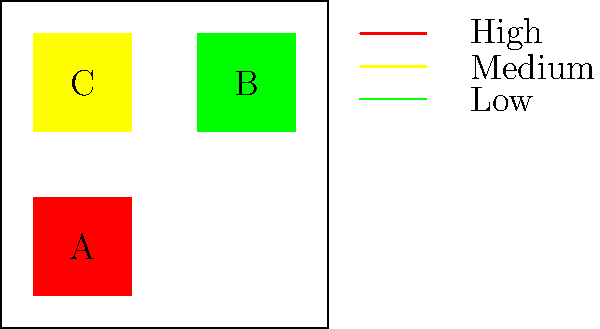Based on the heatmap of visitor engagement in the museum layout, which exhibit area should be prioritized for improvement to increase overall visitor engagement? To determine which exhibit area should be prioritized for improvement, we need to analyze the heatmap and consider the following steps:

1. Interpret the heatmap colors:
   - Red (region A): High engagement
   - Yellow (region C): Medium engagement
   - Green (region B): Low engagement

2. Assess the current engagement levels:
   - Region A is already performing well with high engagement
   - Region C has moderate engagement
   - Region B has the lowest engagement

3. Consider the potential for improvement:
   - Improving the highest-performing area (A) may yield diminishing returns
   - The medium-performing area (C) has some room for improvement
   - The lowest-performing area (B) has the most potential for significant improvement

4. Evaluate the impact on overall engagement:
   - Improving area B from low to medium or high engagement would have the most substantial effect on overall visitor engagement

5. Consider the museum's goals:
   - As a museum dedicated to the history of marginalized groups, ensuring engagement across all exhibits is crucial for comprehensive education

Given these considerations, prioritizing improvement in area B (the green, low-engagement region) would likely result in the most significant increase in overall visitor engagement. This area has the most room for improvement and could potentially bring its engagement level up to match or exceed the other areas.
Answer: Area B (green, low-engagement region) 